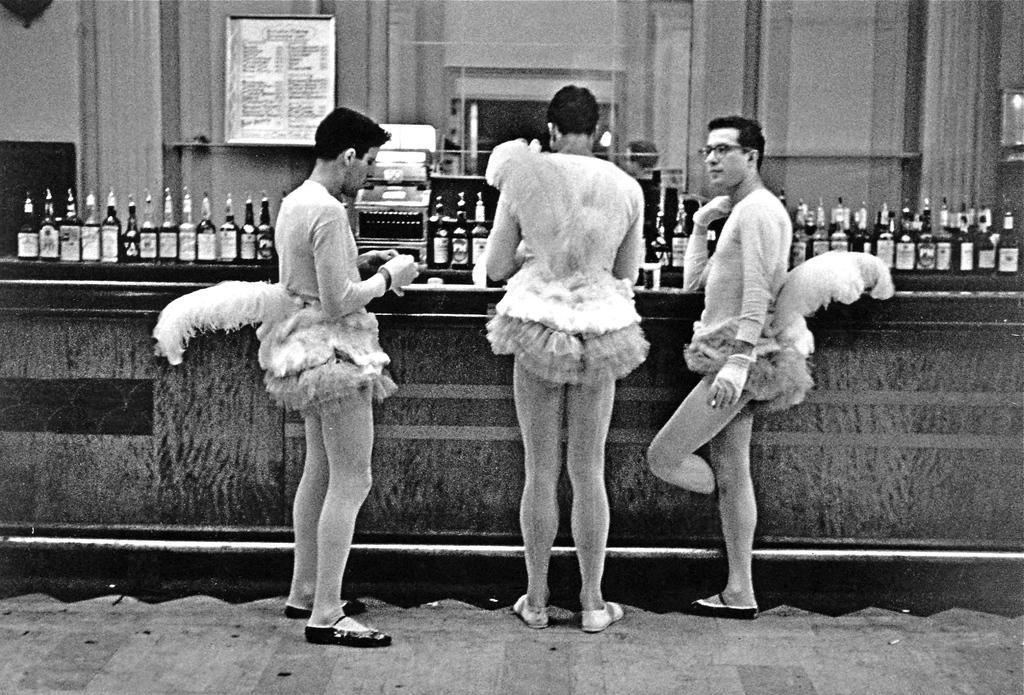Please provide a concise description of this image. In this image I can see three persons wearing a forks and standing in front of the table , on the table I can see bottles and at the top I can see the wall. 